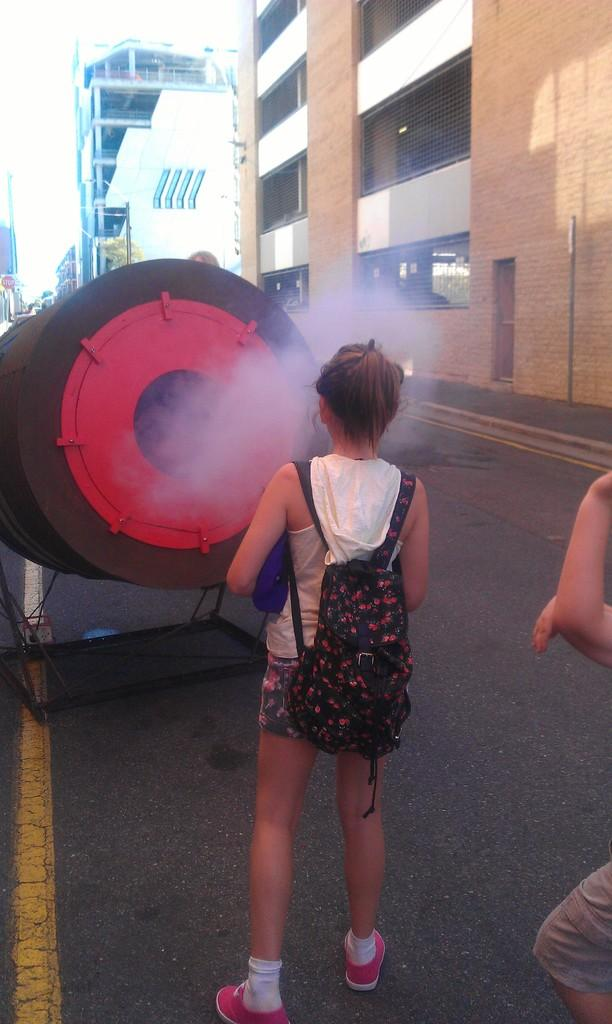Who is the main subject in the image? There is a girl standing in the image. What is the girl holding in the image? The girl is carrying a bag. Can you describe the color of the object in the image? The object in the image has black and red colors. What can be seen in the background of the image? There are buildings visible at the right side of the image. What type of book can be seen on the coast in the image? There is no book or coast present in the image. Can you tell me how many veins are visible on the girl's arm in the image? There is no visible arm or veins on the girl in the image. 